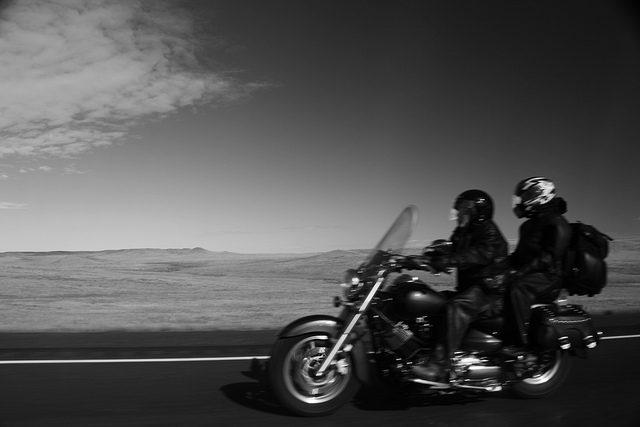Write a detailed description of the given image. The image captures a dynamic scene of two riders on a classic-style motorcycle speeding along a highway. Both riders are clad in full protective gear, including helmets, jackets, and boots, emphasizing their readiness for long-distance travel. The rider at the rear is equipped with a backpack visible over his right shoulder, suggesting they might be on a long journey. They are moving through a vast, open landscape under a clear sky, with subtle clouds adding texture to the scene. The photo's monochrome tone highlights the timeless appeal of motorcycling through expansive natural settings, and the slight blur suggests their swift movement through the environment. 